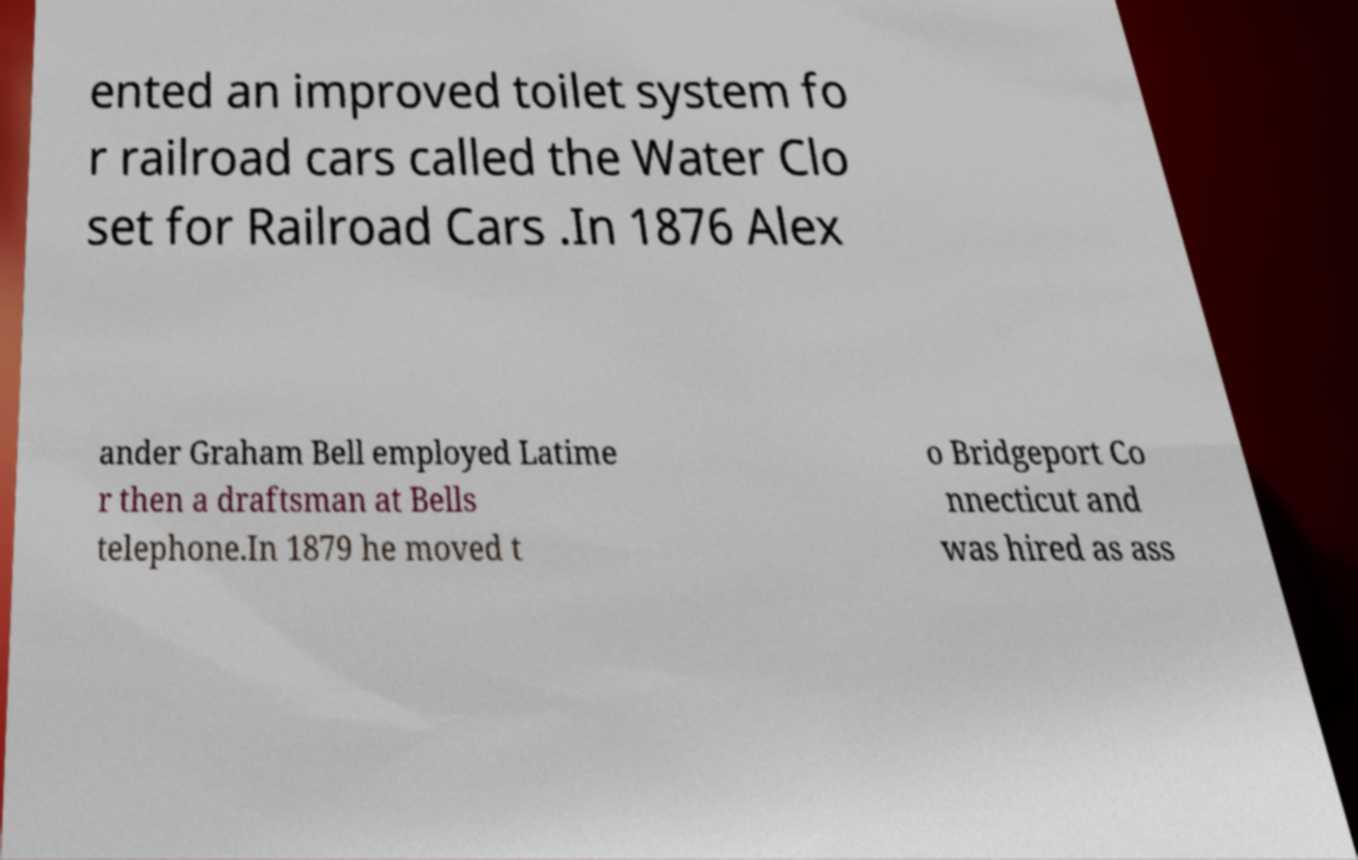What messages or text are displayed in this image? I need them in a readable, typed format. ented an improved toilet system fo r railroad cars called the Water Clo set for Railroad Cars .In 1876 Alex ander Graham Bell employed Latime r then a draftsman at Bells telephone.In 1879 he moved t o Bridgeport Co nnecticut and was hired as ass 